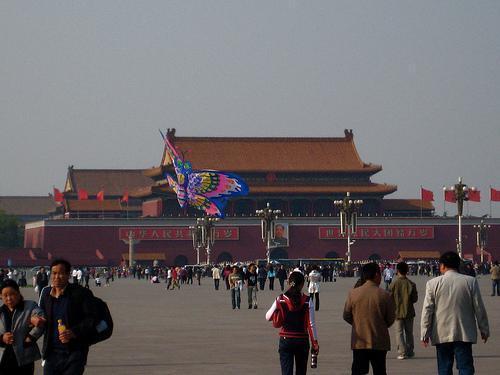How many pictures are on the building in the background?
Give a very brief answer. 1. 